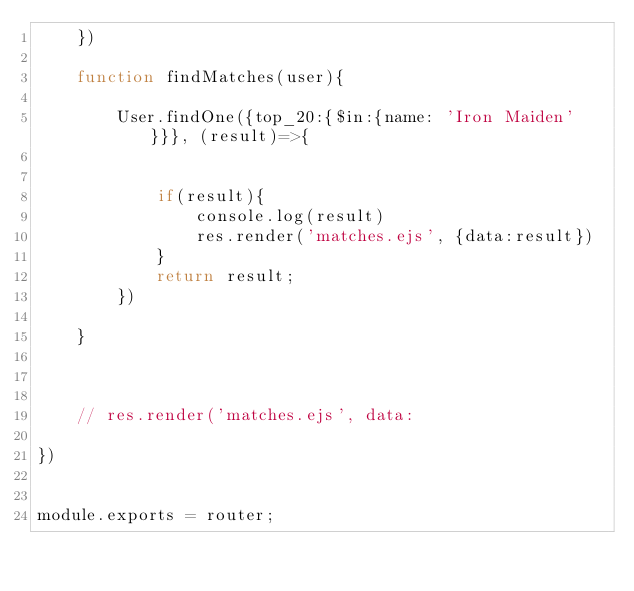Convert code to text. <code><loc_0><loc_0><loc_500><loc_500><_JavaScript_>    })

    function findMatches(user){

        User.findOne({top_20:{$in:{name: 'Iron Maiden'}}}, (result)=>{


            if(result){
                console.log(result)
                res.render('matches.ejs', {data:result})
            }
            return result;
        })
        
    }

    

    // res.render('matches.ejs', data:

})


module.exports = router;</code> 